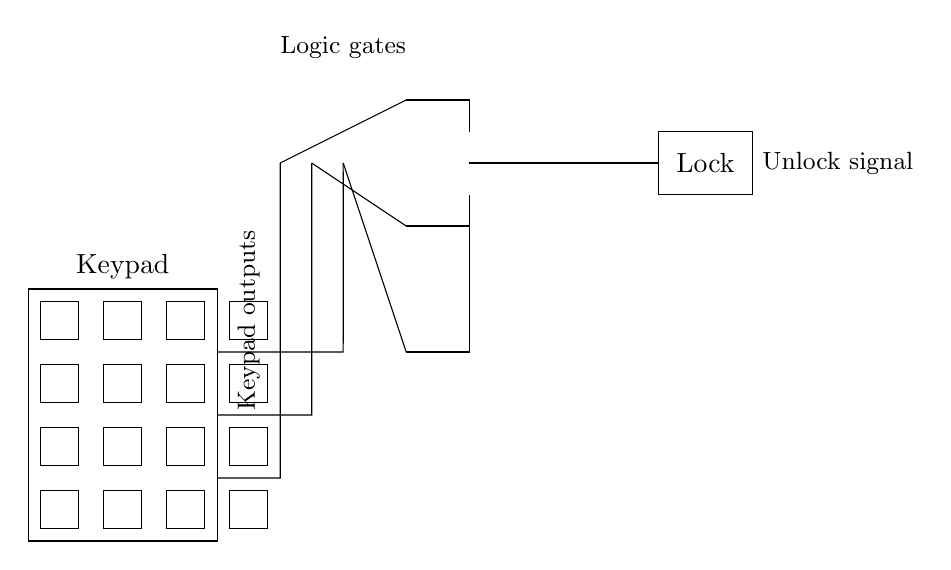What is the main function of the circuit? The circuit is designed to unlock a lock based on inputs from a keypad. The combination entered on the keypad is processed through logic gates, which determine if the correct sequence has been input to send an unlock signal to the lock.
Answer: Unlock a lock How many AND gates are in the circuit? There are three AND gates in the circuit that process the inputs from the keypad. Each gate takes specific input combinations to generate their respective outputs, which are then sent to an OR gate.
Answer: Three What do the outputs from the keypad represent? The outputs from the keypad represent different key presses that can either be logical high or low; these are fed into the AND gates as conditions for generating the unlock signal.
Answer: Key presses Which component generates the final unlock signal? The final unlock signal is generated by the OR gate. It combines the outputs of the three AND gates, allowing the lock to be activated if at least one AND gate provides a high signal.
Answer: OR gate What is the purpose of the AND gates in this circuit? The AND gates are used to verify the specific conditions required for unlocking the lock. They take multiple inputs from the keypad and output a high signal only when all connected inputs meet the necessary criteria.
Answer: Verify conditions 